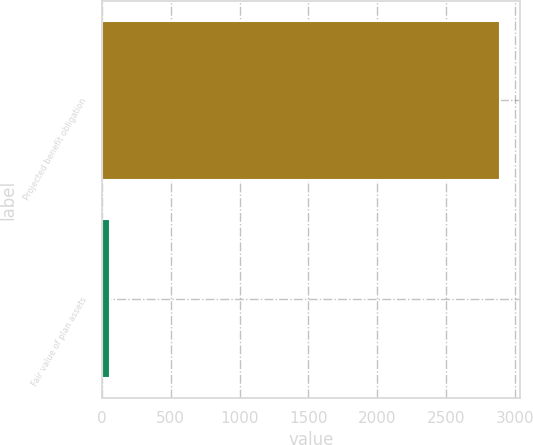Convert chart. <chart><loc_0><loc_0><loc_500><loc_500><bar_chart><fcel>Projected benefit obligation<fcel>Fair value of plan assets<nl><fcel>2895<fcel>59<nl></chart> 